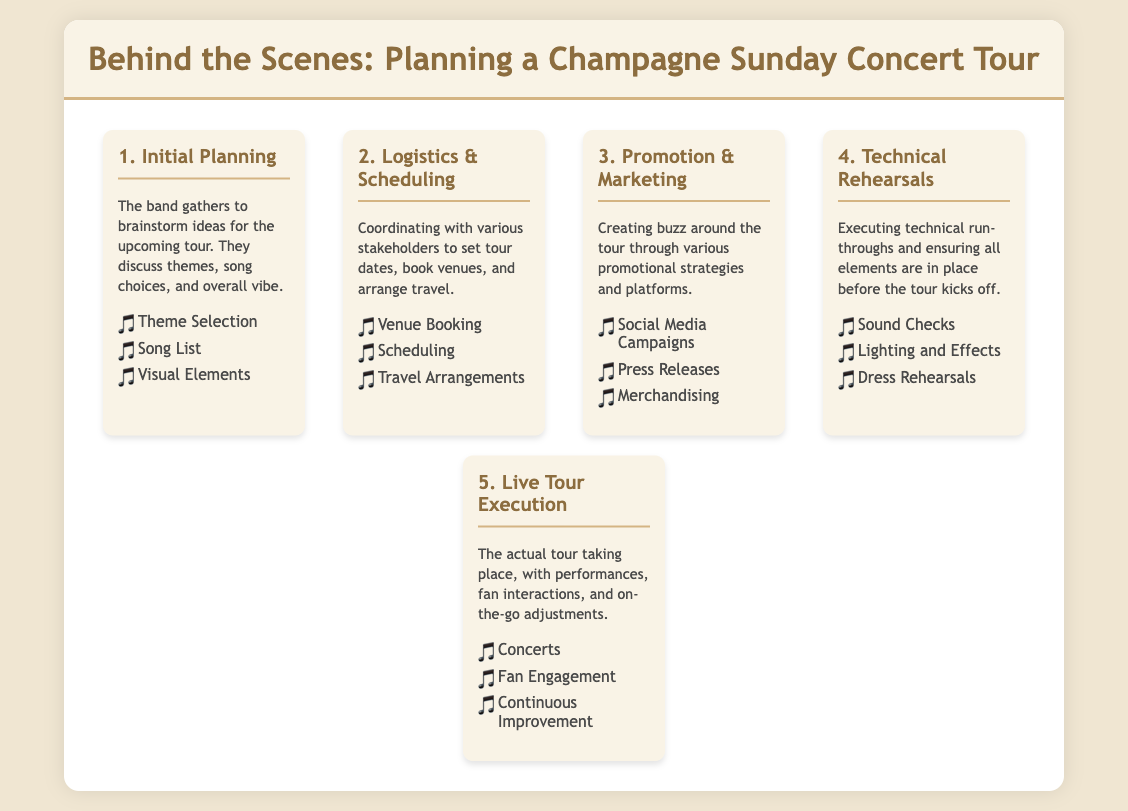What is the first stage in planning a concert tour? The first stage involves brainstorming ideas for the upcoming tour, including discussions on themes and song choices.
Answer: Initial Planning What is one key aspect of the Logistics & Scheduling stage? This stage involves booking venues and arranging travel among various logistical considerations.
Answer: Venue Booking During which stage do technical run-throughs occur? The step where technical rehearsals take place includes sound checks and dress rehearsals to ensure all elements are ready.
Answer: Technical Rehearsals What is a key promotional strategy mentioned in the document? The document discusses using social media campaigns as a strategy to create excitement around the tour.
Answer: Social Media Campaigns How many main stages are there in planning a Champagne Sunday concert tour? The infographic outlines five distinct stages in the planning and execution of a concert tour.
Answer: Five What is the primary focus of the Live Tour Execution stage? This stage emphasizes the actual performances and interactions with fans during the tour itself.
Answer: Performances What aspect is checked during the Technical Rehearsals? The sound checks are one of the critical components addressed to prepare for the tour.
Answer: Sound Checks What kind of feedback is encouraged during the Live Tour Execution stage? The tour emphasizes continuous improvement based on feedback and experiences from the performances.
Answer: Continuous Improvement 